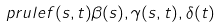Convert formula to latex. <formula><loc_0><loc_0><loc_500><loc_500>\ p r u l e { f ( s , t ) } { \beta ( s ) , \gamma ( s , t ) , \delta ( t ) }</formula> 